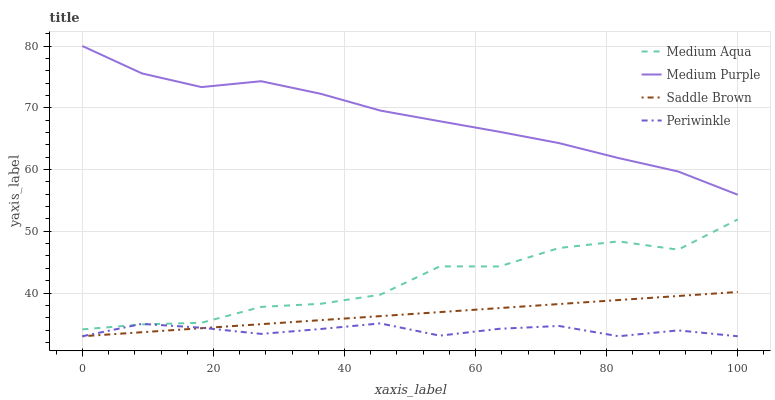Does Periwinkle have the minimum area under the curve?
Answer yes or no. Yes. Does Medium Purple have the maximum area under the curve?
Answer yes or no. Yes. Does Medium Aqua have the minimum area under the curve?
Answer yes or no. No. Does Medium Aqua have the maximum area under the curve?
Answer yes or no. No. Is Saddle Brown the smoothest?
Answer yes or no. Yes. Is Medium Aqua the roughest?
Answer yes or no. Yes. Is Periwinkle the smoothest?
Answer yes or no. No. Is Periwinkle the roughest?
Answer yes or no. No. Does Periwinkle have the lowest value?
Answer yes or no. Yes. Does Medium Aqua have the lowest value?
Answer yes or no. No. Does Medium Purple have the highest value?
Answer yes or no. Yes. Does Medium Aqua have the highest value?
Answer yes or no. No. Is Medium Aqua less than Medium Purple?
Answer yes or no. Yes. Is Medium Purple greater than Medium Aqua?
Answer yes or no. Yes. Does Saddle Brown intersect Periwinkle?
Answer yes or no. Yes. Is Saddle Brown less than Periwinkle?
Answer yes or no. No. Is Saddle Brown greater than Periwinkle?
Answer yes or no. No. Does Medium Aqua intersect Medium Purple?
Answer yes or no. No. 